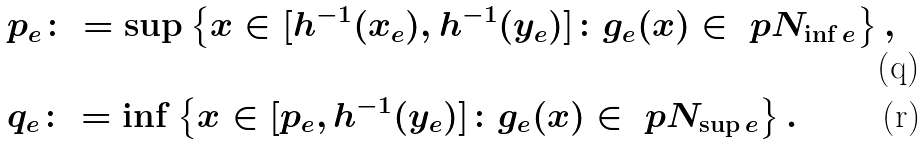Convert formula to latex. <formula><loc_0><loc_0><loc_500><loc_500>& p _ { e } \colon = \sup \left \{ x \in [ h ^ { - 1 } ( x _ { e } ) , h ^ { - 1 } ( y _ { e } ) ] \colon g _ { e } ( x ) \in \ p N _ { \inf e } \right \} , \\ & q _ { e } \colon = \inf \left \{ x \in [ p _ { e } , h ^ { - 1 } ( y _ { e } ) ] \colon g _ { e } ( x ) \in \ p N _ { \sup e } \right \} .</formula> 